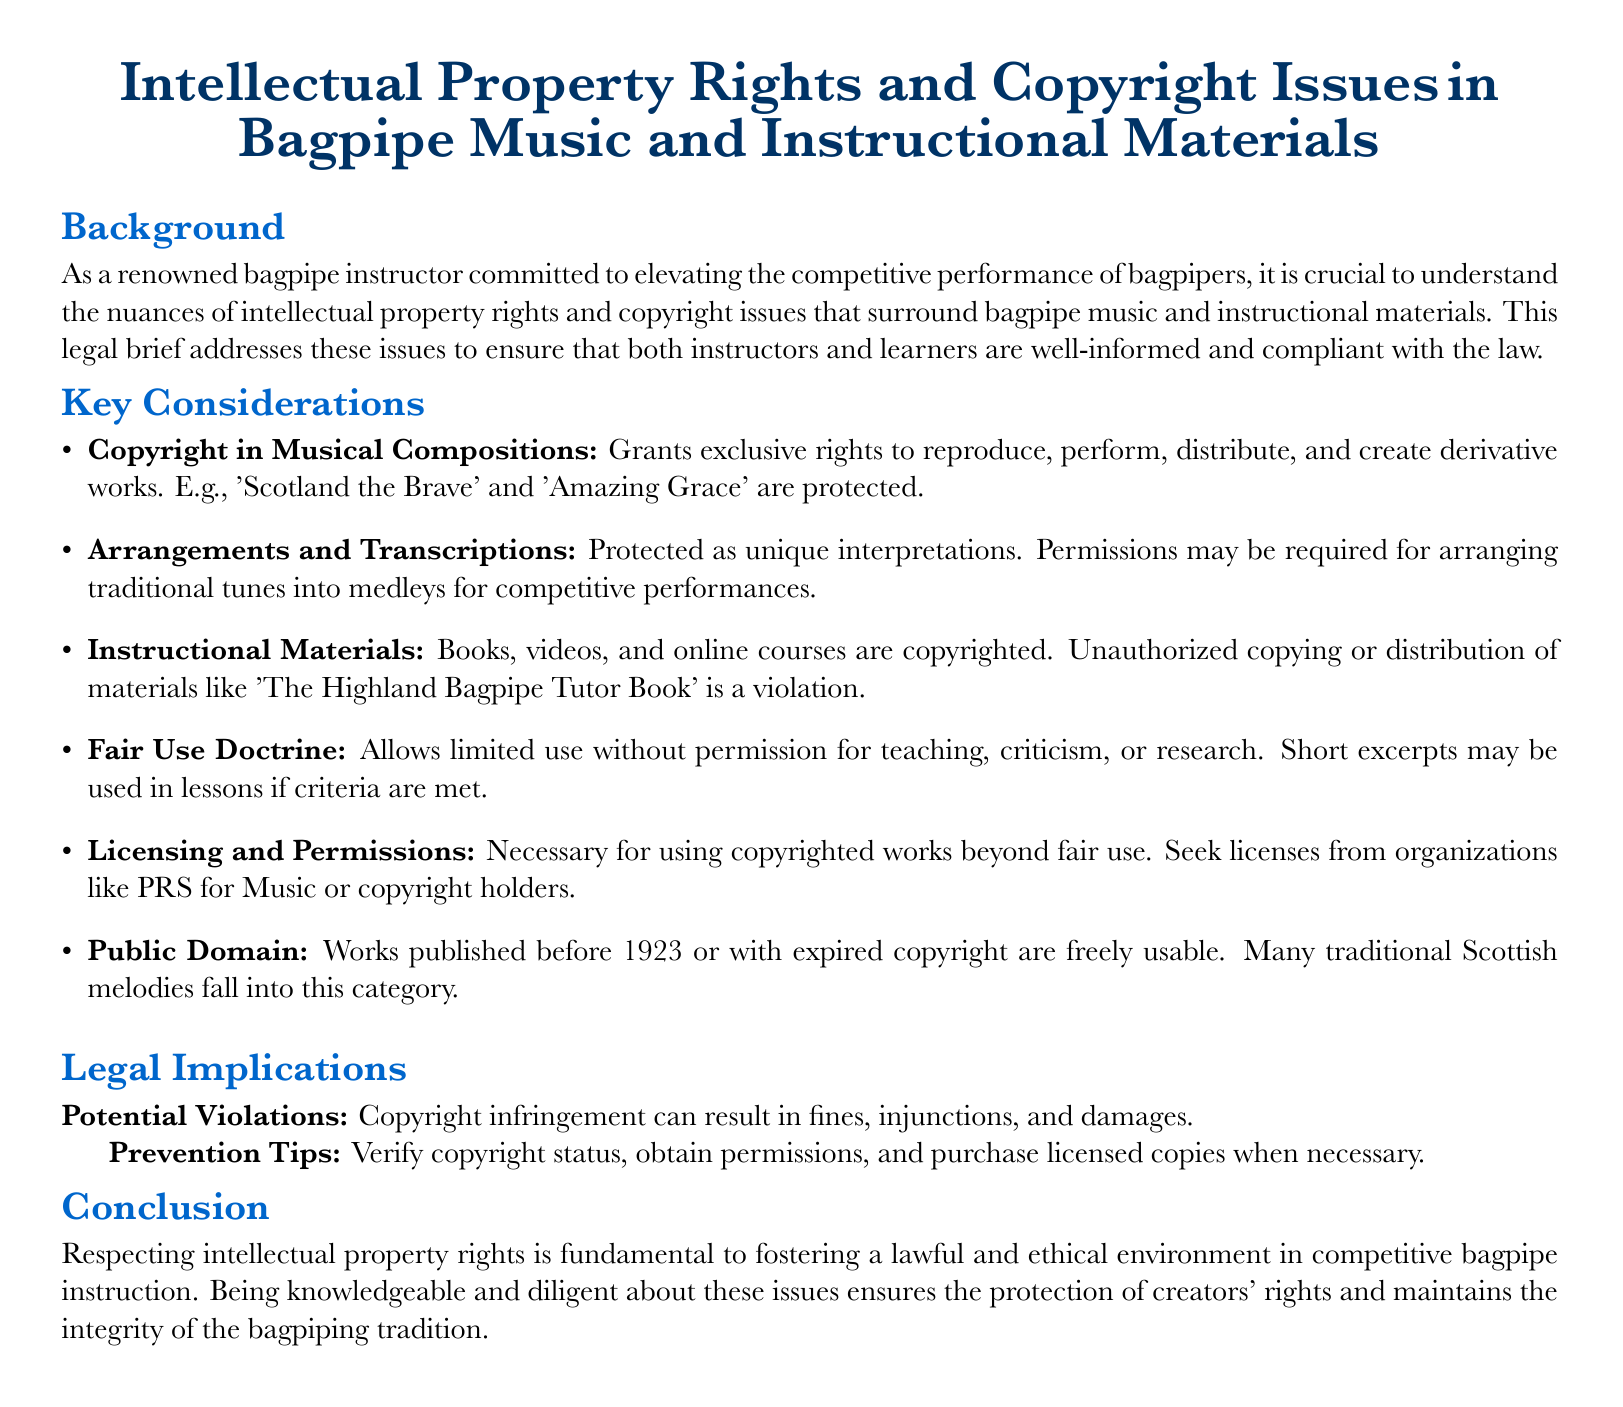What are the exclusive rights granted by copyright? The exclusive rights granted by copyright include reproduction, performance, distribution, and creation of derivative works.
Answer: Reproduction, performance, distribution, and creation of derivative works What is the fair use doctrine? The fair use doctrine allows limited use of copyrighted material without permission for purposes such as teaching, criticism, or research.
Answer: Allows limited use without permission Which materials are copyrighted according to the brief? Instructional materials such as books, videos, and online courses are copyrighted.
Answer: Books, videos, and online courses What year marks works entering public domain? Works published before this year or with expired copyright are freely usable.
Answer: 1923 What can result from copyright infringement? Copyright infringement can result in fines, injunctions, and damages.
Answer: Fines, injunctions, and damages What should be verified to prevent copyright violations? To prevent copyright violations, it is essential to verify copyright status.
Answer: Copyright status What are examples of traditional tunes mentioned? Examples of traditional tunes include 'Scotland the Brave' and 'Amazing Grace'.
Answer: 'Scotland the Brave' and 'Amazing Grace' Which organizations should licenses be sought from? Licenses should be sought from organizations like PRS for Music or copyright holders.
Answer: PRS for Music What is a potential violation mentioned in the brief? A potential violation is unauthorized copying or distribution of copyrighted instructional materials.
Answer: Unauthorized copying or distribution 